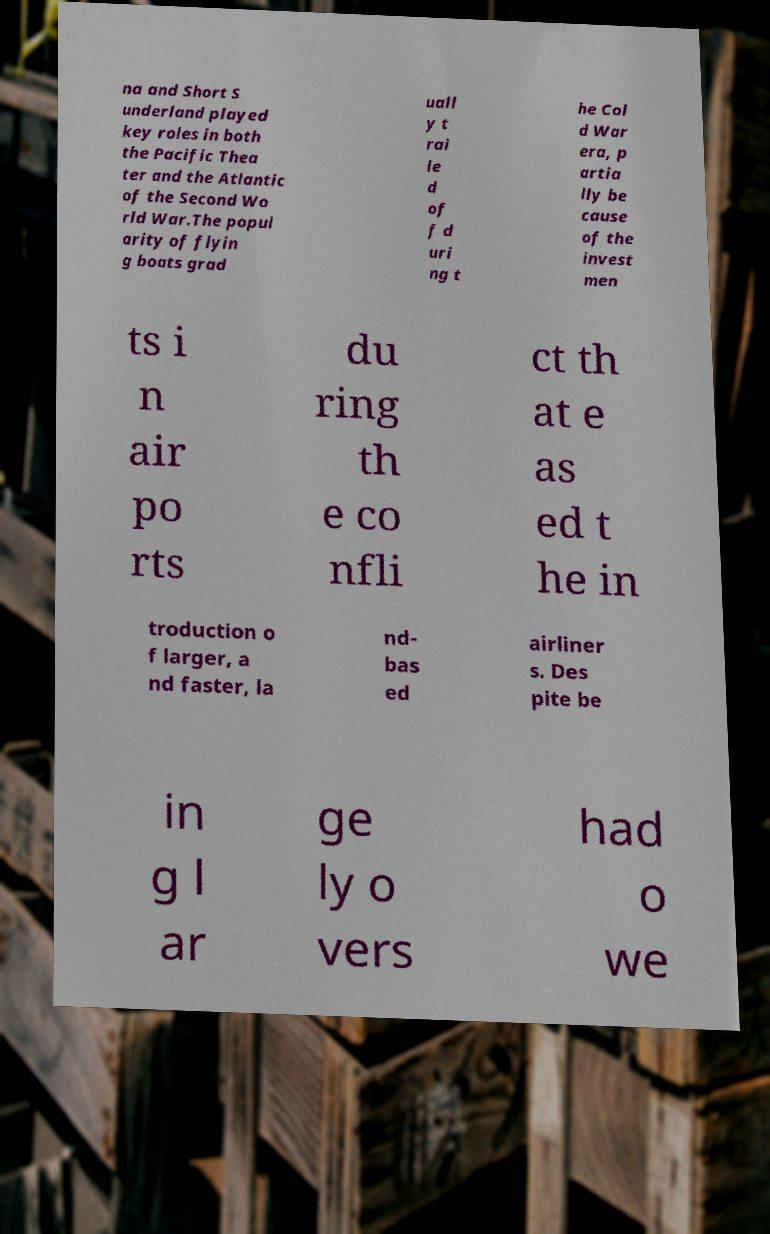Could you assist in decoding the text presented in this image and type it out clearly? na and Short S underland played key roles in both the Pacific Thea ter and the Atlantic of the Second Wo rld War.The popul arity of flyin g boats grad uall y t rai le d of f d uri ng t he Col d War era, p artia lly be cause of the invest men ts i n air po rts du ring th e co nfli ct th at e as ed t he in troduction o f larger, a nd faster, la nd- bas ed airliner s. Des pite be in g l ar ge ly o vers had o we 